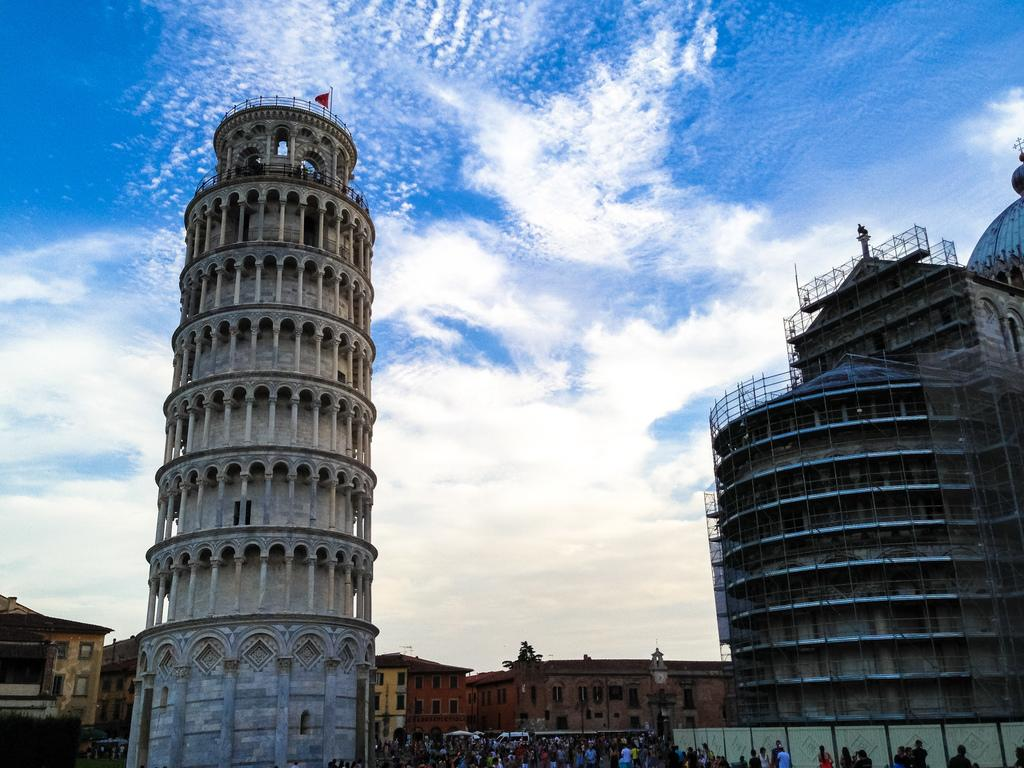What type of structures can be seen in the image? There are buildings in the image. What is the condition of the sky in the image? The sky is cloudy in the image. Can you identify any living beings in the image? Yes, there are people in the image. What type of natural element is present in the image? There is a tree in the image. What other unspecified objects can be seen in the image? There are unspecified objects in the image. What type of prose is being recited by the toad sitting on the calculator in the image? There is no toad, calculator, or prose present in the image. What type of creature is shown interacting with the calculator on the tree in the image? There is no creature shown interacting with a calculator in the image; only the buildings, sky, people, tree, and unspecified objects are present. 